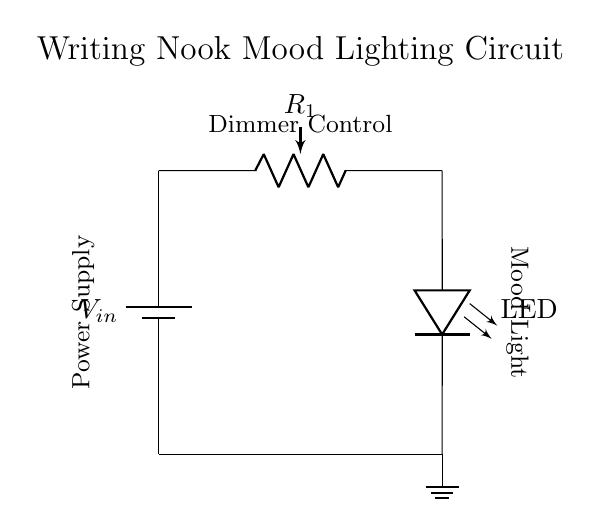What is the power source of this circuit? The circuit diagram shows a battery as the power source, indicated by the symbol for a battery on the left side, labeled as V in.
Answer: Battery What component is used to dim the light? A potentiometer labeled R1 is used to adjust the resistance in the circuit, which controls the brightness of the LED by varying the voltage across it.
Answer: Potentiometer What is the output component that produces light? The circuit contains an LED, which is responsible for emitting light when current flows through it. It is indicated in the diagram with a specific symbol for an LED.
Answer: LED How many components are in this circuit? The circuit includes three main components: a battery, a potentiometer, and an LED. We count each of these distinct components for the total.
Answer: Three What happens to the LED brightness when resistance increases? Increasing the resistance of the potentiometer R1 reduces the current flowing through the LED, leading to dimmer light, as less voltage is dedicated to the LED.
Answer: Dims What is the primary function of the circuit? The main purpose of the circuit is to provide mood lighting, which can be adjusted by the user via the potentiometer, making the light suitable for a writing nook atmosphere.
Answer: Mood lighting 